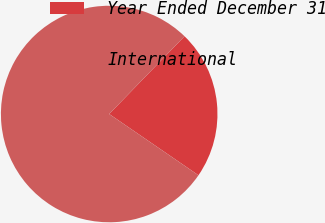Convert chart. <chart><loc_0><loc_0><loc_500><loc_500><pie_chart><fcel>Year Ended December 31<fcel>International<nl><fcel>22.32%<fcel>77.68%<nl></chart> 